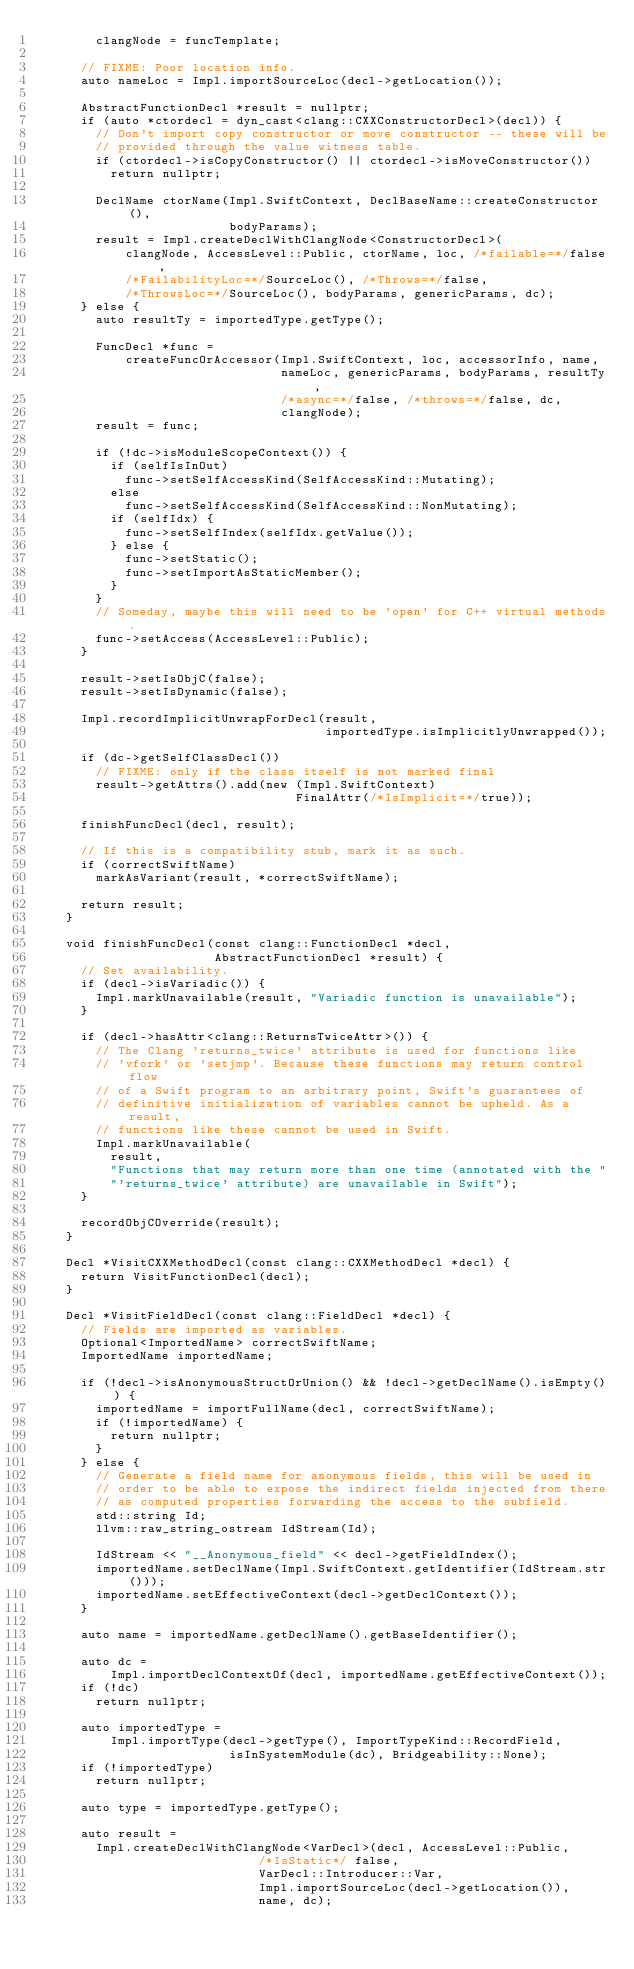Convert code to text. <code><loc_0><loc_0><loc_500><loc_500><_C++_>        clangNode = funcTemplate;

      // FIXME: Poor location info.
      auto nameLoc = Impl.importSourceLoc(decl->getLocation());

      AbstractFunctionDecl *result = nullptr;
      if (auto *ctordecl = dyn_cast<clang::CXXConstructorDecl>(decl)) {
        // Don't import copy constructor or move constructor -- these will be
        // provided through the value witness table.
        if (ctordecl->isCopyConstructor() || ctordecl->isMoveConstructor())
          return nullptr;

        DeclName ctorName(Impl.SwiftContext, DeclBaseName::createConstructor(),
                          bodyParams);
        result = Impl.createDeclWithClangNode<ConstructorDecl>(
            clangNode, AccessLevel::Public, ctorName, loc, /*failable=*/false,
            /*FailabilityLoc=*/SourceLoc(), /*Throws=*/false,
            /*ThrowsLoc=*/SourceLoc(), bodyParams, genericParams, dc);
      } else {
        auto resultTy = importedType.getType();

        FuncDecl *func =
            createFuncOrAccessor(Impl.SwiftContext, loc, accessorInfo, name,
                                 nameLoc, genericParams, bodyParams, resultTy,
                                 /*async=*/false, /*throws=*/false, dc,
                                 clangNode);
        result = func;

        if (!dc->isModuleScopeContext()) {
          if (selfIsInOut)
            func->setSelfAccessKind(SelfAccessKind::Mutating);
          else
            func->setSelfAccessKind(SelfAccessKind::NonMutating);
          if (selfIdx) {
            func->setSelfIndex(selfIdx.getValue());
          } else {
            func->setStatic();
            func->setImportAsStaticMember();
          }
        }
        // Someday, maybe this will need to be 'open' for C++ virtual methods.
        func->setAccess(AccessLevel::Public);
      }

      result->setIsObjC(false);
      result->setIsDynamic(false);

      Impl.recordImplicitUnwrapForDecl(result,
                                       importedType.isImplicitlyUnwrapped());

      if (dc->getSelfClassDecl())
        // FIXME: only if the class itself is not marked final
        result->getAttrs().add(new (Impl.SwiftContext)
                                   FinalAttr(/*IsImplicit=*/true));

      finishFuncDecl(decl, result);

      // If this is a compatibility stub, mark it as such.
      if (correctSwiftName)
        markAsVariant(result, *correctSwiftName);

      return result;
    }

    void finishFuncDecl(const clang::FunctionDecl *decl,
                        AbstractFunctionDecl *result) {
      // Set availability.
      if (decl->isVariadic()) {
        Impl.markUnavailable(result, "Variadic function is unavailable");
      }

      if (decl->hasAttr<clang::ReturnsTwiceAttr>()) {
        // The Clang 'returns_twice' attribute is used for functions like
        // 'vfork' or 'setjmp'. Because these functions may return control flow
        // of a Swift program to an arbitrary point, Swift's guarantees of
        // definitive initialization of variables cannot be upheld. As a result,
        // functions like these cannot be used in Swift.
        Impl.markUnavailable(
          result,
          "Functions that may return more than one time (annotated with the "
          "'returns_twice' attribute) are unavailable in Swift");
      }

      recordObjCOverride(result);
    }

    Decl *VisitCXXMethodDecl(const clang::CXXMethodDecl *decl) {
      return VisitFunctionDecl(decl);
    }

    Decl *VisitFieldDecl(const clang::FieldDecl *decl) {
      // Fields are imported as variables.
      Optional<ImportedName> correctSwiftName;
      ImportedName importedName;

      if (!decl->isAnonymousStructOrUnion() && !decl->getDeclName().isEmpty()) {
        importedName = importFullName(decl, correctSwiftName);
        if (!importedName) {
          return nullptr;
        }
      } else {
        // Generate a field name for anonymous fields, this will be used in
        // order to be able to expose the indirect fields injected from there
        // as computed properties forwarding the access to the subfield.
        std::string Id;
        llvm::raw_string_ostream IdStream(Id);

        IdStream << "__Anonymous_field" << decl->getFieldIndex();
        importedName.setDeclName(Impl.SwiftContext.getIdentifier(IdStream.str()));
        importedName.setEffectiveContext(decl->getDeclContext());
      }

      auto name = importedName.getDeclName().getBaseIdentifier();

      auto dc =
          Impl.importDeclContextOf(decl, importedName.getEffectiveContext());
      if (!dc)
        return nullptr;

      auto importedType =
          Impl.importType(decl->getType(), ImportTypeKind::RecordField,
                          isInSystemModule(dc), Bridgeability::None);
      if (!importedType)
        return nullptr;

      auto type = importedType.getType();

      auto result =
        Impl.createDeclWithClangNode<VarDecl>(decl, AccessLevel::Public,
                              /*IsStatic*/ false,
                              VarDecl::Introducer::Var,
                              Impl.importSourceLoc(decl->getLocation()),
                              name, dc);</code> 